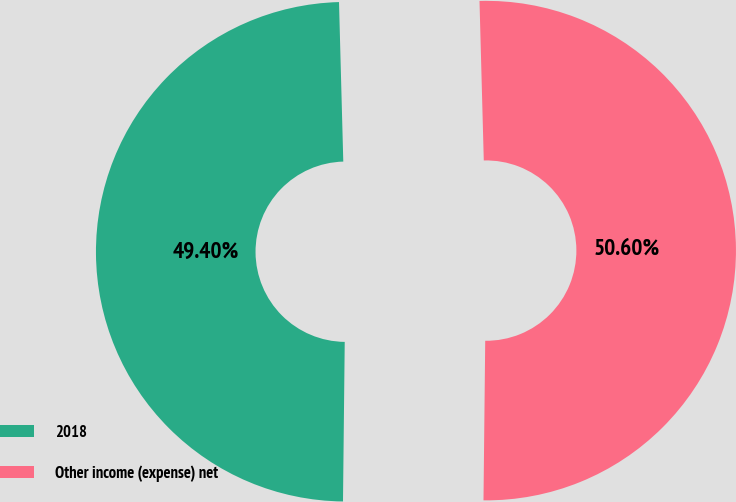<chart> <loc_0><loc_0><loc_500><loc_500><pie_chart><fcel>2018<fcel>Other income (expense) net<nl><fcel>49.4%<fcel>50.6%<nl></chart> 